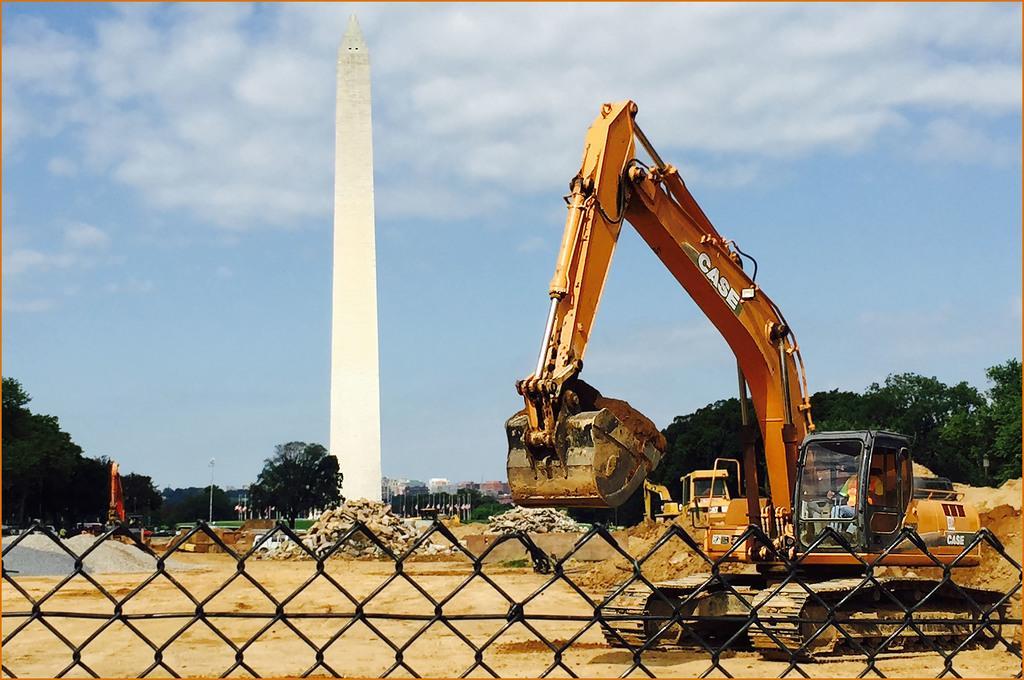Please provide a concise description of this image. At the bottom of the image there is a fencing. To the right side of the image there is a proclainer. In the background of the image there is a memorial. There is sky. There are trees. 